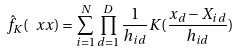<formula> <loc_0><loc_0><loc_500><loc_500>\hat { f } _ { K } ( \ x x ) = \sum _ { i = 1 } ^ { N } \prod _ { d = 1 } ^ { D } \frac { 1 } { h _ { i d } } K ( \frac { x _ { d } - X _ { i d } } { h _ { i d } } )</formula> 